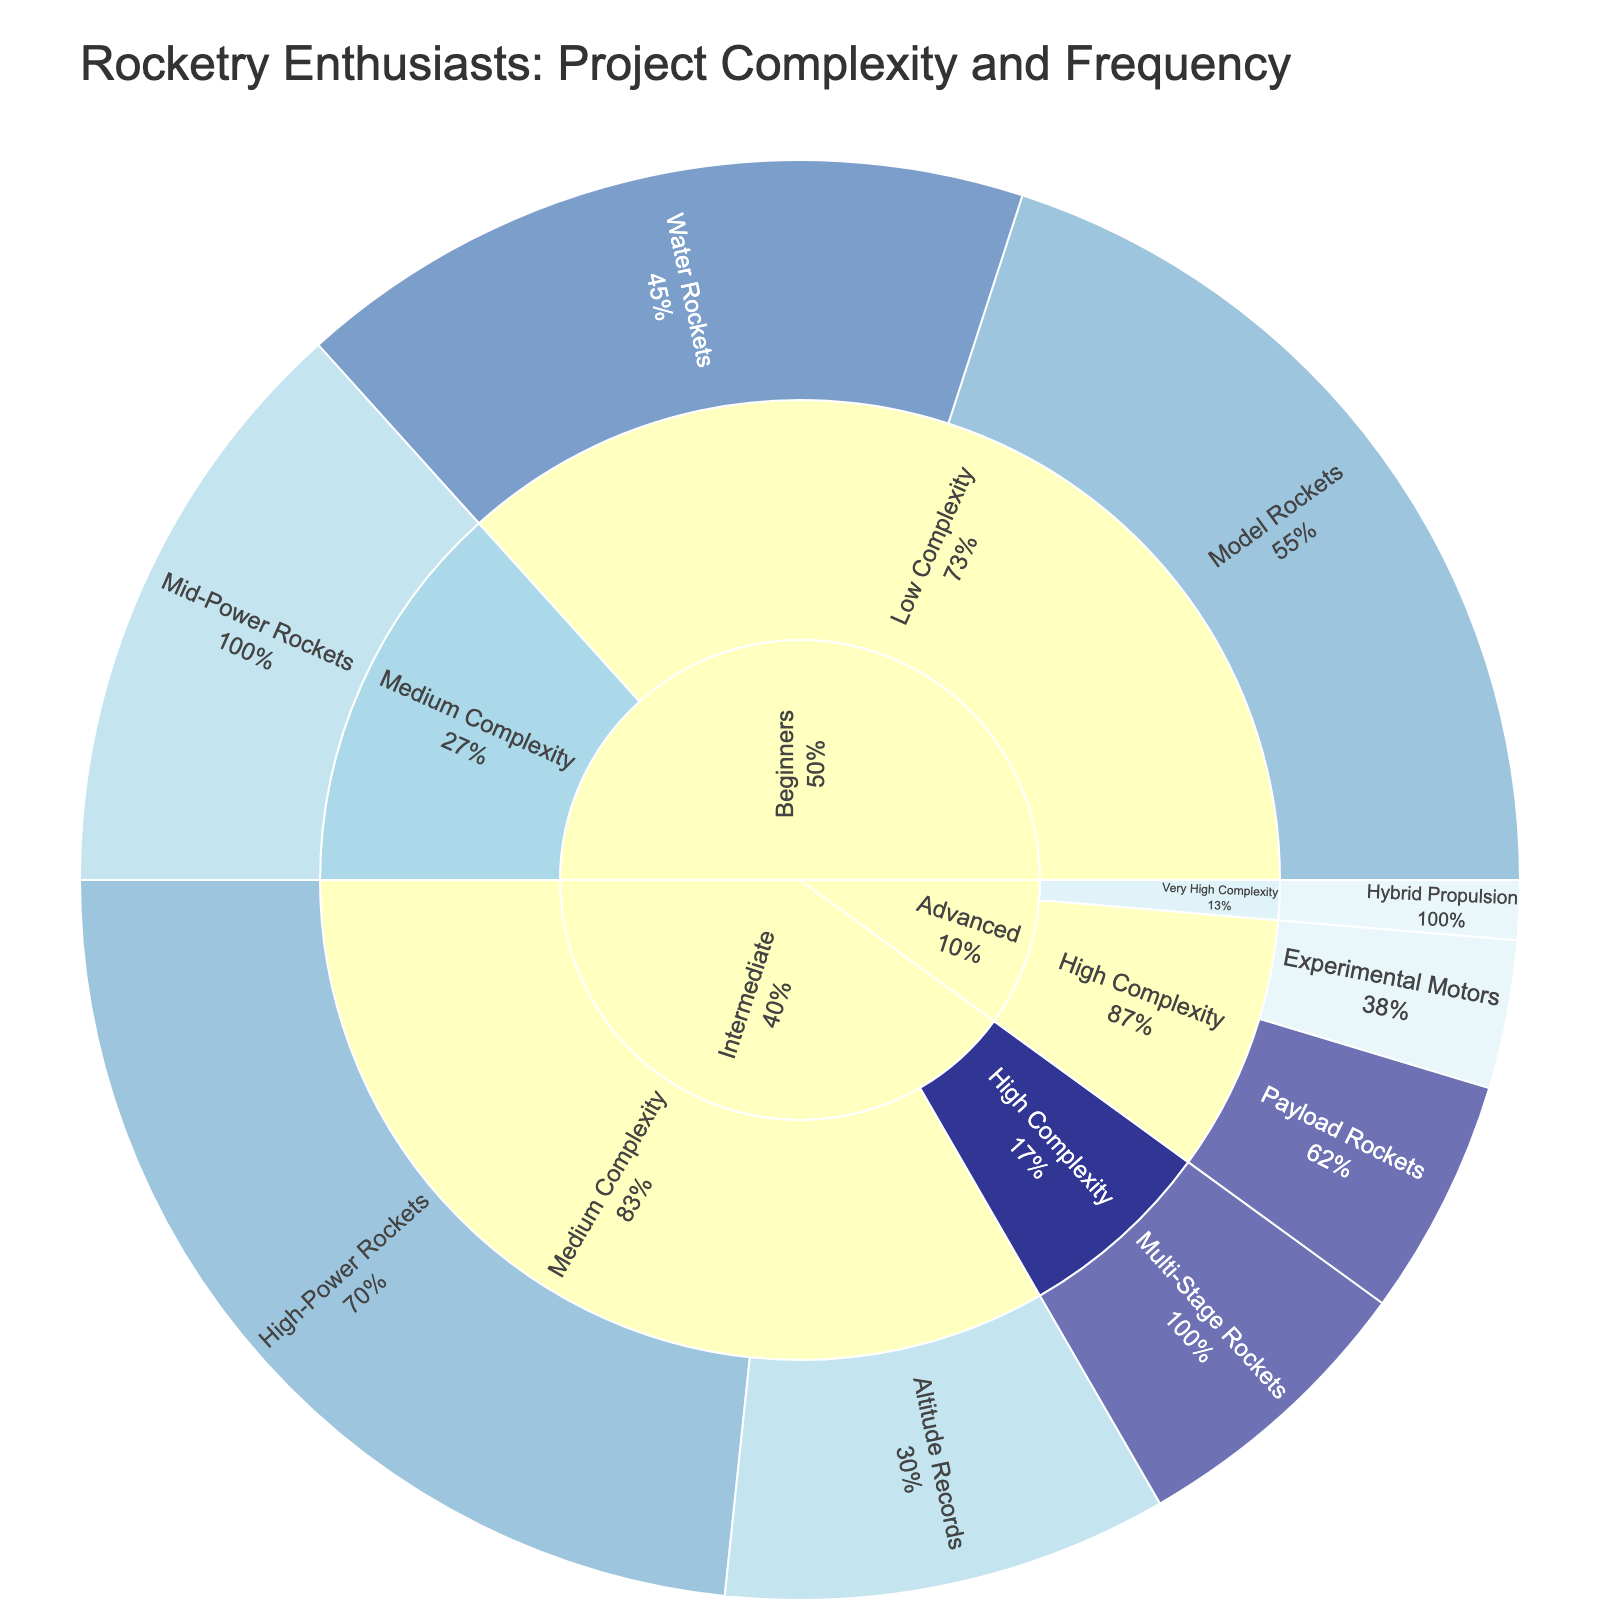what is the title of the plot? The title of the plot is displayed at the top of the figure in larger font.
Answer: Rocketry Enthusiasts: Project Complexity and Frequency how many values are associated with the "Intermediate" category? The "Intermediate" category consists of subcategories and their respective project types. Summing up the values for "Intermediate" from the plot: 35 + 15 + 10 = 60.
Answer: 60 which project type under "Beginners" is most frequent? Under the "Beginners" category, the project types are "Model Rockets," "Water Rockets," and "Mid-Power Rockets." Observing the frequency data: "Water Rockets" (weekly) is most frequent compared to the other types.
Answer: Water Rockets what is the total number of customers for high complexity projects? To find the total number of customers for high complexity projects, sum up the values for all subcategories and categories with high complexity: 10 (Intermediate) + 5 (Advanced) + 8 (Advanced) = 23.
Answer: 23 which subcategory has the lowest number of customers? Observing all the subcategories, "Hybrid Propulsion" in "Advanced" has the lowest value of 2.
Answer: Hybrid Propulsion for the "Monthly" frequency, which category has the most projects? Observing the plot for "Monthly" frequency, the categories with monthly projects are "Beginners" and "Intermediate." "Intermediate" has only one (High-Power Rockets), and "Beginners" has one (Model Rockets). Thus, "Beginners" and "Intermediate" both have monthly projects but different project types.
Answer: Beginners and Intermediate are tied how many projects are in the "Model Rockets" subcategory? The "Model Rockets" subcategory under "Beginners" has a value of 30 indicating 30 projects.
Answer: 30 compare the customer base between "Medium Complexity" and "Very High Complexity" projects in the "Advanced" category. Summing up the values for "Medium Complexity" and "Very High Complexity" within "Advanced": "Medium Complexity" is not present, whereas "Very High Complexity" (Hybrid Propulsion) is 2. Therefore, "Very High Complexity" has 2.
Answer: Very High Complexity: 2 which category has more high complexity projects, "Intermediate" or "Advanced"? Counting the values for "High Complexity" in both categories: "Intermediate" has 10 projects, whereas "Advanced" has 5 + 8 = 13 projects. Therefore, "Advanced" has more high complexity projects.
Answer: Advanced 